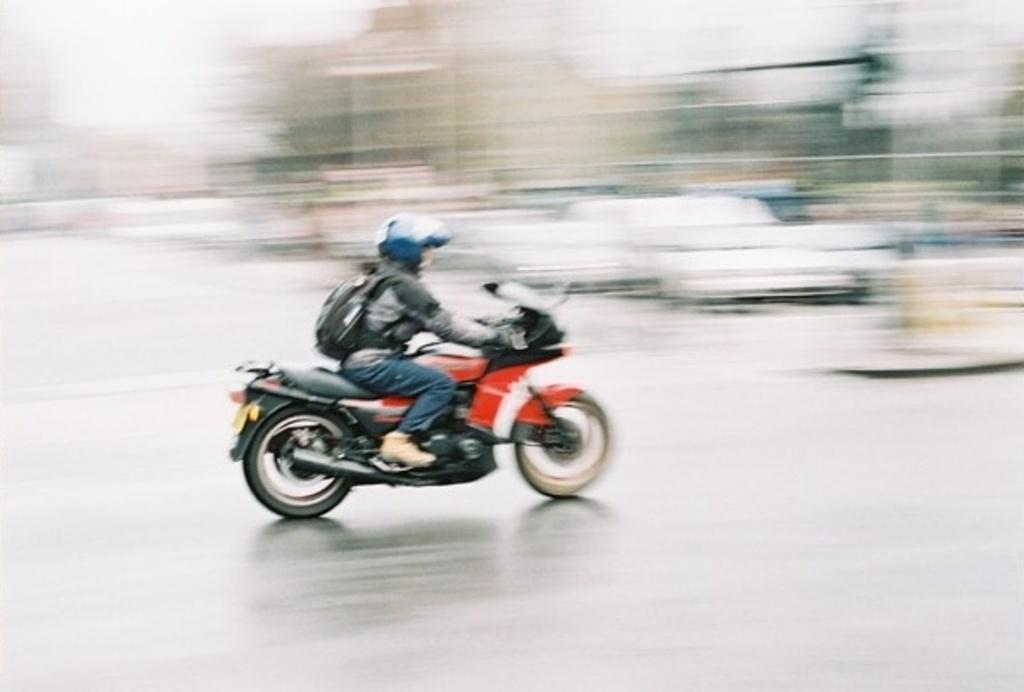Who is the main subject in the image? There is a man in the image. What is the man doing in the image? The man is riding a motorbike. What safety precaution is the man taking while riding the motorbike? The man is wearing a helmet. What else is the man carrying while riding the motorbike? The man is carrying a bag. What type of brush is the man using to paint the children in the image? There are no brushes, children, or painting activity depicted in the image. 